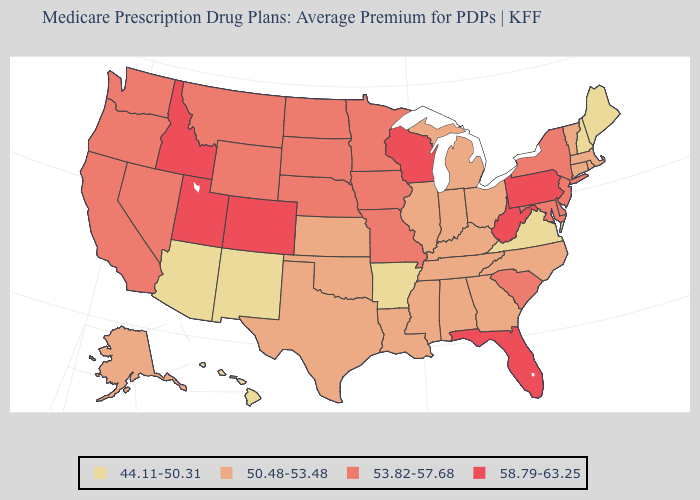Which states have the highest value in the USA?
Quick response, please. Colorado, Florida, Idaho, Pennsylvania, Utah, Wisconsin, West Virginia. Which states have the lowest value in the USA?
Short answer required. Arkansas, Arizona, Hawaii, Maine, New Hampshire, New Mexico, Virginia. Does Nebraska have the lowest value in the MidWest?
Answer briefly. No. Name the states that have a value in the range 58.79-63.25?
Answer briefly. Colorado, Florida, Idaho, Pennsylvania, Utah, Wisconsin, West Virginia. Does Florida have the lowest value in the South?
Give a very brief answer. No. Does Florida have the lowest value in the USA?
Answer briefly. No. What is the value of Maine?
Quick response, please. 44.11-50.31. What is the value of Tennessee?
Be succinct. 50.48-53.48. Name the states that have a value in the range 50.48-53.48?
Be succinct. Alaska, Alabama, Connecticut, Georgia, Illinois, Indiana, Kansas, Kentucky, Louisiana, Massachusetts, Michigan, Mississippi, North Carolina, Ohio, Oklahoma, Rhode Island, Tennessee, Texas, Vermont. Which states have the lowest value in the MidWest?
Answer briefly. Illinois, Indiana, Kansas, Michigan, Ohio. Does Oklahoma have the lowest value in the South?
Answer briefly. No. Among the states that border Maryland , does Pennsylvania have the highest value?
Concise answer only. Yes. Does the map have missing data?
Be succinct. No. Name the states that have a value in the range 50.48-53.48?
Keep it brief. Alaska, Alabama, Connecticut, Georgia, Illinois, Indiana, Kansas, Kentucky, Louisiana, Massachusetts, Michigan, Mississippi, North Carolina, Ohio, Oklahoma, Rhode Island, Tennessee, Texas, Vermont. Does South Carolina have the lowest value in the USA?
Keep it brief. No. 